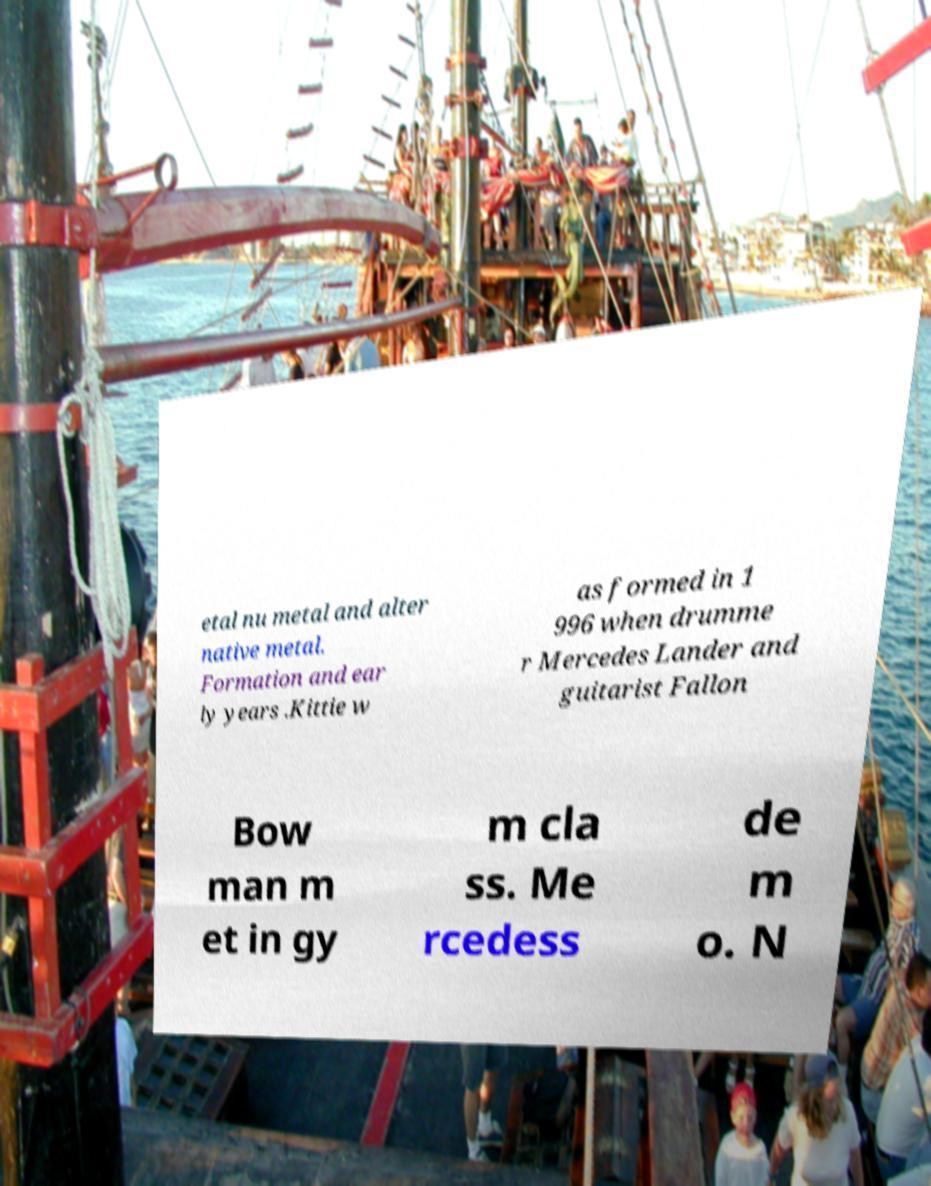What messages or text are displayed in this image? I need them in a readable, typed format. etal nu metal and alter native metal. Formation and ear ly years .Kittie w as formed in 1 996 when drumme r Mercedes Lander and guitarist Fallon Bow man m et in gy m cla ss. Me rcedess de m o. N 